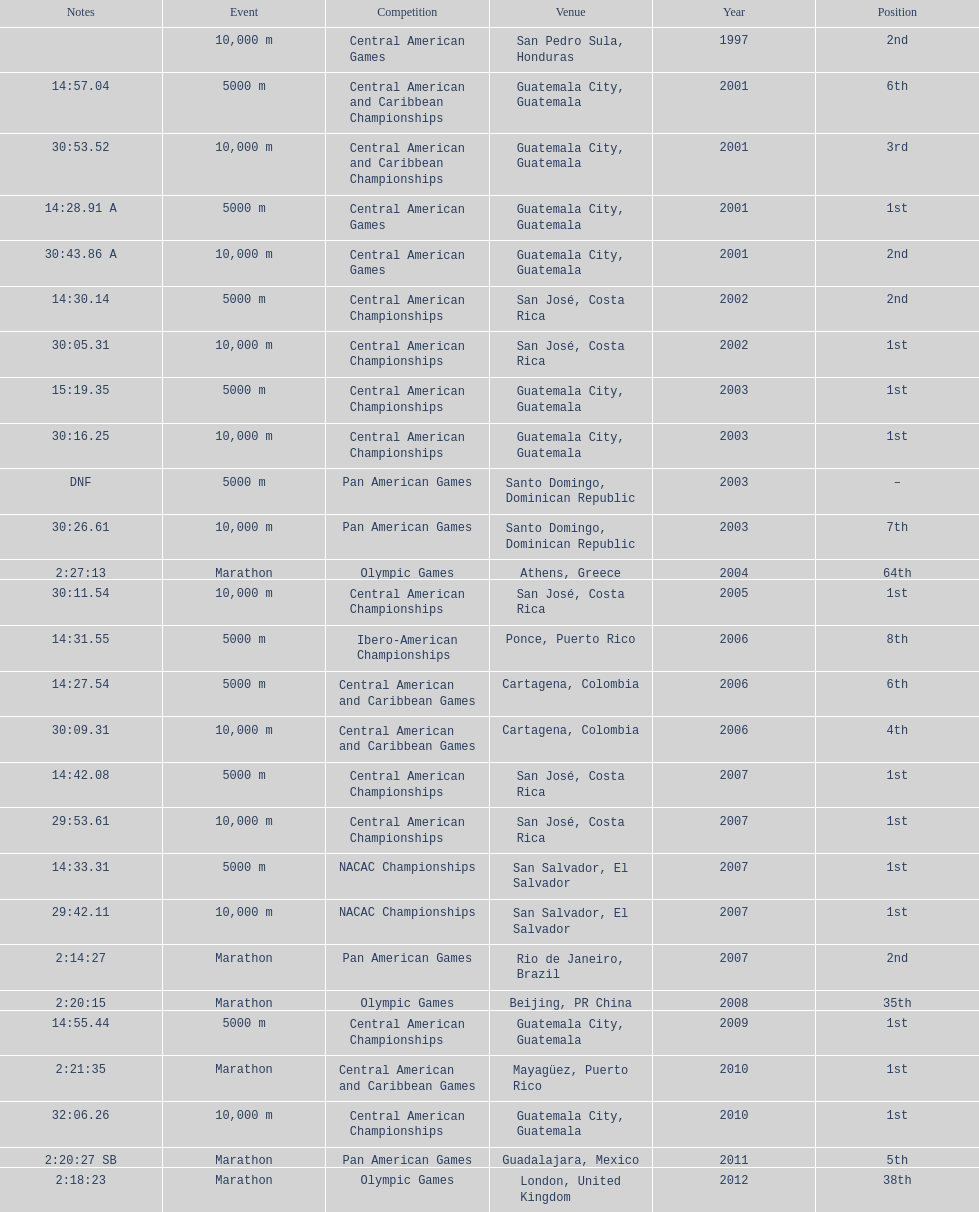Where was the only 64th position held? Athens, Greece. 